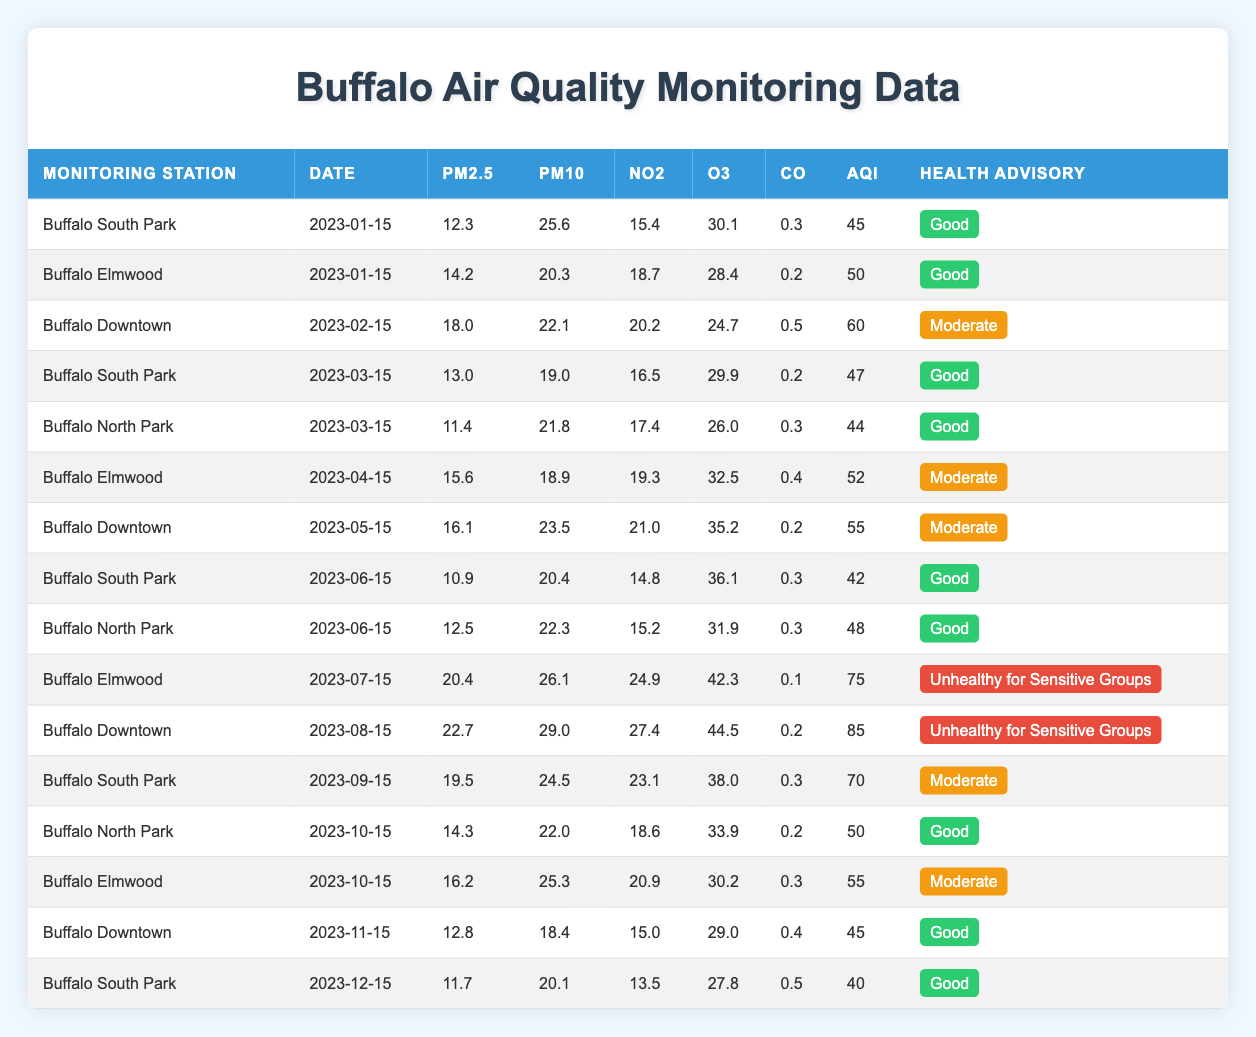What is the AQI value for Buffalo Elmwood on January 15, 2023? From the table, I can directly see that the AQI value for Buffalo Elmwood on January 15, 2023, is 50 in the corresponding row.
Answer: 50 What was the health advisory status for Buffalo South Park on March 15, 2023? Looking at the table, the health advisory for Buffalo South Park on March 15, 2023, is classified as "Good," as indicated in the health advisory column in that row.
Answer: Good Which monitoring station had the highest PM2.5 value recorded, and what was that value? By reviewing the PM2.5 values across all monitoring stations, I can find the maximum value from the rows. The highest value is 22.7 at Buffalo Downtown on August 15, 2023.
Answer: Buffalo Downtown, 22.7 What is the average PM10 measurement across all monitoring stations for the month of June 2023? I identify the PM10 values for all stations in June: 20.4 (South Park), 22.3 (North Park). The average is (20.4 + 22.3) / 2 = 21.35.
Answer: 21.35 Did Buffalo Elmwood ever have an "Unhealthy for Sensitive Groups" health advisory status? I need to check the health advisory statuses for Buffalo Elmwood in the table. Upon reviewing, it is evident that it had "Unhealthy for Sensitive Groups" status on July 15, 2023.
Answer: Yes What was the change in AQI from February 15, 2023 (Downtown) to August 15, 2023 (Downtown)? The AQI for Buffalo Downtown on February 15, 2023, is 60, and on August 15, 2023, it is 85. The change is 85 - 60 = 25, indicating an increase in AQI.
Answer: 25 Which month had the best air quality on average across all monitoring stations? I need to first calculate the average AQI for each month. After analyzing the monthly data, January has the average AQI of 47.5, which is the lowest among all months. Therefore, January has the best air quality.
Answer: January How many times did the AQI fall in the "Good" category during the year? By scanning the health advisory column, I can count the instances of "Good." It appears in January (2), March (2), June (2), October (2), November, and December, totaling 9 occurrences.
Answer: 9 What was the maximum NO2 level and in which month and monitoring station was it recorded? I look at the NO2 values to find the maximum. The highest NO2 is 27.4, recorded at Buffalo Downtown on August 15, 2023.
Answer: 27.4, Buffalo Downtown, August 